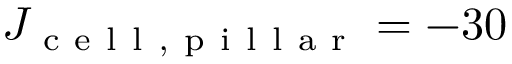<formula> <loc_0><loc_0><loc_500><loc_500>J _ { c e l l , p i l l a r } = - 3 0</formula> 